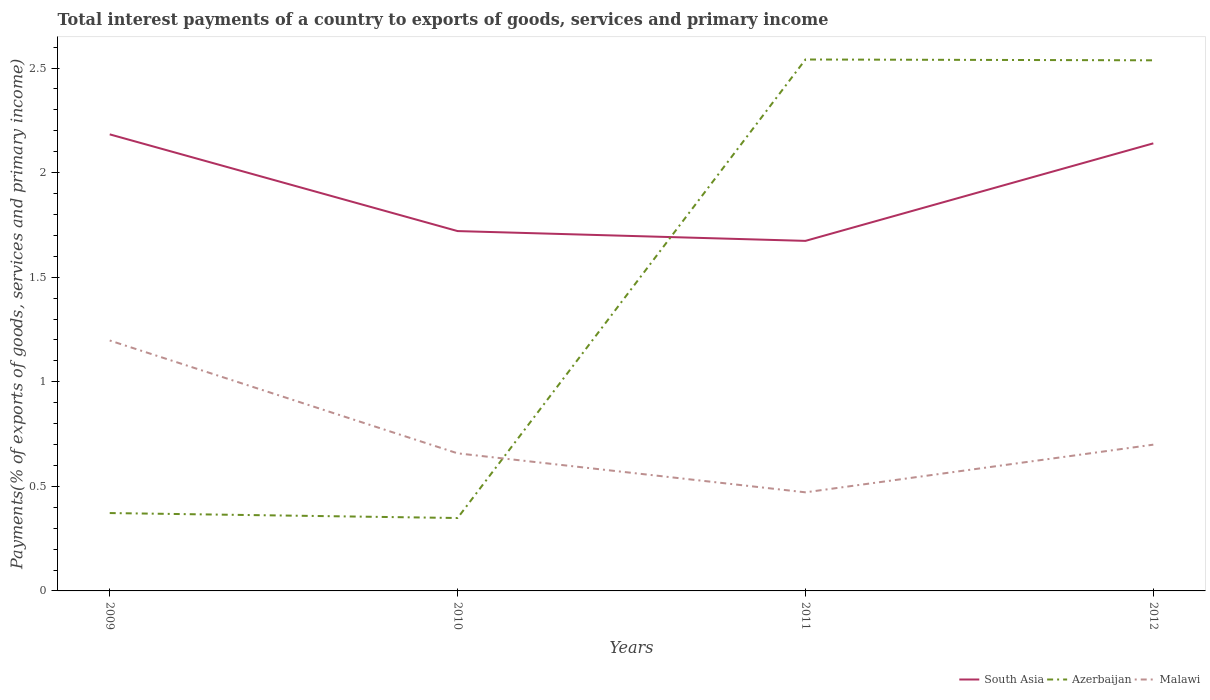Does the line corresponding to Azerbaijan intersect with the line corresponding to Malawi?
Your answer should be compact. Yes. Across all years, what is the maximum total interest payments in Malawi?
Your answer should be compact. 0.47. What is the total total interest payments in South Asia in the graph?
Offer a terse response. 0.46. What is the difference between the highest and the second highest total interest payments in Azerbaijan?
Make the answer very short. 2.19. What is the difference between the highest and the lowest total interest payments in Azerbaijan?
Offer a terse response. 2. How many lines are there?
Your answer should be very brief. 3. What is the difference between two consecutive major ticks on the Y-axis?
Your response must be concise. 0.5. Are the values on the major ticks of Y-axis written in scientific E-notation?
Offer a terse response. No. Does the graph contain grids?
Ensure brevity in your answer.  No. What is the title of the graph?
Your answer should be very brief. Total interest payments of a country to exports of goods, services and primary income. What is the label or title of the Y-axis?
Provide a succinct answer. Payments(% of exports of goods, services and primary income). What is the Payments(% of exports of goods, services and primary income) of South Asia in 2009?
Keep it short and to the point. 2.18. What is the Payments(% of exports of goods, services and primary income) of Azerbaijan in 2009?
Give a very brief answer. 0.37. What is the Payments(% of exports of goods, services and primary income) in Malawi in 2009?
Give a very brief answer. 1.2. What is the Payments(% of exports of goods, services and primary income) of South Asia in 2010?
Make the answer very short. 1.72. What is the Payments(% of exports of goods, services and primary income) in Azerbaijan in 2010?
Offer a terse response. 0.35. What is the Payments(% of exports of goods, services and primary income) in Malawi in 2010?
Your answer should be compact. 0.66. What is the Payments(% of exports of goods, services and primary income) of South Asia in 2011?
Ensure brevity in your answer.  1.67. What is the Payments(% of exports of goods, services and primary income) of Azerbaijan in 2011?
Your answer should be compact. 2.54. What is the Payments(% of exports of goods, services and primary income) of Malawi in 2011?
Make the answer very short. 0.47. What is the Payments(% of exports of goods, services and primary income) in South Asia in 2012?
Your response must be concise. 2.14. What is the Payments(% of exports of goods, services and primary income) in Azerbaijan in 2012?
Your answer should be compact. 2.54. What is the Payments(% of exports of goods, services and primary income) of Malawi in 2012?
Offer a very short reply. 0.7. Across all years, what is the maximum Payments(% of exports of goods, services and primary income) in South Asia?
Your answer should be compact. 2.18. Across all years, what is the maximum Payments(% of exports of goods, services and primary income) of Azerbaijan?
Your response must be concise. 2.54. Across all years, what is the maximum Payments(% of exports of goods, services and primary income) in Malawi?
Offer a terse response. 1.2. Across all years, what is the minimum Payments(% of exports of goods, services and primary income) in South Asia?
Keep it short and to the point. 1.67. Across all years, what is the minimum Payments(% of exports of goods, services and primary income) of Azerbaijan?
Your answer should be very brief. 0.35. Across all years, what is the minimum Payments(% of exports of goods, services and primary income) in Malawi?
Provide a short and direct response. 0.47. What is the total Payments(% of exports of goods, services and primary income) of South Asia in the graph?
Ensure brevity in your answer.  7.72. What is the total Payments(% of exports of goods, services and primary income) of Azerbaijan in the graph?
Provide a succinct answer. 5.8. What is the total Payments(% of exports of goods, services and primary income) in Malawi in the graph?
Make the answer very short. 3.03. What is the difference between the Payments(% of exports of goods, services and primary income) in South Asia in 2009 and that in 2010?
Your answer should be compact. 0.46. What is the difference between the Payments(% of exports of goods, services and primary income) of Azerbaijan in 2009 and that in 2010?
Your answer should be very brief. 0.02. What is the difference between the Payments(% of exports of goods, services and primary income) of Malawi in 2009 and that in 2010?
Your response must be concise. 0.54. What is the difference between the Payments(% of exports of goods, services and primary income) in South Asia in 2009 and that in 2011?
Provide a succinct answer. 0.51. What is the difference between the Payments(% of exports of goods, services and primary income) in Azerbaijan in 2009 and that in 2011?
Your answer should be compact. -2.17. What is the difference between the Payments(% of exports of goods, services and primary income) in Malawi in 2009 and that in 2011?
Provide a succinct answer. 0.73. What is the difference between the Payments(% of exports of goods, services and primary income) of South Asia in 2009 and that in 2012?
Provide a succinct answer. 0.04. What is the difference between the Payments(% of exports of goods, services and primary income) of Azerbaijan in 2009 and that in 2012?
Provide a succinct answer. -2.16. What is the difference between the Payments(% of exports of goods, services and primary income) in Malawi in 2009 and that in 2012?
Keep it short and to the point. 0.5. What is the difference between the Payments(% of exports of goods, services and primary income) in South Asia in 2010 and that in 2011?
Keep it short and to the point. 0.05. What is the difference between the Payments(% of exports of goods, services and primary income) of Azerbaijan in 2010 and that in 2011?
Your answer should be compact. -2.19. What is the difference between the Payments(% of exports of goods, services and primary income) of Malawi in 2010 and that in 2011?
Provide a succinct answer. 0.19. What is the difference between the Payments(% of exports of goods, services and primary income) in South Asia in 2010 and that in 2012?
Make the answer very short. -0.42. What is the difference between the Payments(% of exports of goods, services and primary income) of Azerbaijan in 2010 and that in 2012?
Your response must be concise. -2.19. What is the difference between the Payments(% of exports of goods, services and primary income) in Malawi in 2010 and that in 2012?
Your response must be concise. -0.04. What is the difference between the Payments(% of exports of goods, services and primary income) in South Asia in 2011 and that in 2012?
Offer a very short reply. -0.47. What is the difference between the Payments(% of exports of goods, services and primary income) of Azerbaijan in 2011 and that in 2012?
Make the answer very short. 0. What is the difference between the Payments(% of exports of goods, services and primary income) of Malawi in 2011 and that in 2012?
Offer a very short reply. -0.23. What is the difference between the Payments(% of exports of goods, services and primary income) of South Asia in 2009 and the Payments(% of exports of goods, services and primary income) of Azerbaijan in 2010?
Your response must be concise. 1.83. What is the difference between the Payments(% of exports of goods, services and primary income) of South Asia in 2009 and the Payments(% of exports of goods, services and primary income) of Malawi in 2010?
Provide a short and direct response. 1.53. What is the difference between the Payments(% of exports of goods, services and primary income) in Azerbaijan in 2009 and the Payments(% of exports of goods, services and primary income) in Malawi in 2010?
Your answer should be compact. -0.29. What is the difference between the Payments(% of exports of goods, services and primary income) of South Asia in 2009 and the Payments(% of exports of goods, services and primary income) of Azerbaijan in 2011?
Your answer should be compact. -0.36. What is the difference between the Payments(% of exports of goods, services and primary income) of South Asia in 2009 and the Payments(% of exports of goods, services and primary income) of Malawi in 2011?
Provide a short and direct response. 1.71. What is the difference between the Payments(% of exports of goods, services and primary income) in Azerbaijan in 2009 and the Payments(% of exports of goods, services and primary income) in Malawi in 2011?
Make the answer very short. -0.1. What is the difference between the Payments(% of exports of goods, services and primary income) in South Asia in 2009 and the Payments(% of exports of goods, services and primary income) in Azerbaijan in 2012?
Make the answer very short. -0.35. What is the difference between the Payments(% of exports of goods, services and primary income) in South Asia in 2009 and the Payments(% of exports of goods, services and primary income) in Malawi in 2012?
Make the answer very short. 1.48. What is the difference between the Payments(% of exports of goods, services and primary income) of Azerbaijan in 2009 and the Payments(% of exports of goods, services and primary income) of Malawi in 2012?
Offer a very short reply. -0.33. What is the difference between the Payments(% of exports of goods, services and primary income) of South Asia in 2010 and the Payments(% of exports of goods, services and primary income) of Azerbaijan in 2011?
Offer a terse response. -0.82. What is the difference between the Payments(% of exports of goods, services and primary income) of South Asia in 2010 and the Payments(% of exports of goods, services and primary income) of Malawi in 2011?
Keep it short and to the point. 1.25. What is the difference between the Payments(% of exports of goods, services and primary income) of Azerbaijan in 2010 and the Payments(% of exports of goods, services and primary income) of Malawi in 2011?
Keep it short and to the point. -0.12. What is the difference between the Payments(% of exports of goods, services and primary income) of South Asia in 2010 and the Payments(% of exports of goods, services and primary income) of Azerbaijan in 2012?
Offer a very short reply. -0.82. What is the difference between the Payments(% of exports of goods, services and primary income) of South Asia in 2010 and the Payments(% of exports of goods, services and primary income) of Malawi in 2012?
Your answer should be compact. 1.02. What is the difference between the Payments(% of exports of goods, services and primary income) of Azerbaijan in 2010 and the Payments(% of exports of goods, services and primary income) of Malawi in 2012?
Your answer should be very brief. -0.35. What is the difference between the Payments(% of exports of goods, services and primary income) of South Asia in 2011 and the Payments(% of exports of goods, services and primary income) of Azerbaijan in 2012?
Your response must be concise. -0.86. What is the difference between the Payments(% of exports of goods, services and primary income) of South Asia in 2011 and the Payments(% of exports of goods, services and primary income) of Malawi in 2012?
Offer a terse response. 0.97. What is the difference between the Payments(% of exports of goods, services and primary income) of Azerbaijan in 2011 and the Payments(% of exports of goods, services and primary income) of Malawi in 2012?
Provide a succinct answer. 1.84. What is the average Payments(% of exports of goods, services and primary income) of South Asia per year?
Provide a succinct answer. 1.93. What is the average Payments(% of exports of goods, services and primary income) in Azerbaijan per year?
Give a very brief answer. 1.45. What is the average Payments(% of exports of goods, services and primary income) of Malawi per year?
Keep it short and to the point. 0.76. In the year 2009, what is the difference between the Payments(% of exports of goods, services and primary income) of South Asia and Payments(% of exports of goods, services and primary income) of Azerbaijan?
Make the answer very short. 1.81. In the year 2009, what is the difference between the Payments(% of exports of goods, services and primary income) in South Asia and Payments(% of exports of goods, services and primary income) in Malawi?
Provide a short and direct response. 0.99. In the year 2009, what is the difference between the Payments(% of exports of goods, services and primary income) of Azerbaijan and Payments(% of exports of goods, services and primary income) of Malawi?
Give a very brief answer. -0.82. In the year 2010, what is the difference between the Payments(% of exports of goods, services and primary income) of South Asia and Payments(% of exports of goods, services and primary income) of Azerbaijan?
Your response must be concise. 1.37. In the year 2010, what is the difference between the Payments(% of exports of goods, services and primary income) in South Asia and Payments(% of exports of goods, services and primary income) in Malawi?
Your answer should be very brief. 1.06. In the year 2010, what is the difference between the Payments(% of exports of goods, services and primary income) in Azerbaijan and Payments(% of exports of goods, services and primary income) in Malawi?
Ensure brevity in your answer.  -0.31. In the year 2011, what is the difference between the Payments(% of exports of goods, services and primary income) in South Asia and Payments(% of exports of goods, services and primary income) in Azerbaijan?
Your response must be concise. -0.87. In the year 2011, what is the difference between the Payments(% of exports of goods, services and primary income) in South Asia and Payments(% of exports of goods, services and primary income) in Malawi?
Your answer should be compact. 1.2. In the year 2011, what is the difference between the Payments(% of exports of goods, services and primary income) in Azerbaijan and Payments(% of exports of goods, services and primary income) in Malawi?
Provide a short and direct response. 2.07. In the year 2012, what is the difference between the Payments(% of exports of goods, services and primary income) in South Asia and Payments(% of exports of goods, services and primary income) in Azerbaijan?
Offer a very short reply. -0.4. In the year 2012, what is the difference between the Payments(% of exports of goods, services and primary income) in South Asia and Payments(% of exports of goods, services and primary income) in Malawi?
Provide a succinct answer. 1.44. In the year 2012, what is the difference between the Payments(% of exports of goods, services and primary income) of Azerbaijan and Payments(% of exports of goods, services and primary income) of Malawi?
Offer a very short reply. 1.84. What is the ratio of the Payments(% of exports of goods, services and primary income) in South Asia in 2009 to that in 2010?
Ensure brevity in your answer.  1.27. What is the ratio of the Payments(% of exports of goods, services and primary income) in Azerbaijan in 2009 to that in 2010?
Make the answer very short. 1.07. What is the ratio of the Payments(% of exports of goods, services and primary income) of Malawi in 2009 to that in 2010?
Your answer should be compact. 1.82. What is the ratio of the Payments(% of exports of goods, services and primary income) of South Asia in 2009 to that in 2011?
Keep it short and to the point. 1.3. What is the ratio of the Payments(% of exports of goods, services and primary income) in Azerbaijan in 2009 to that in 2011?
Your answer should be very brief. 0.15. What is the ratio of the Payments(% of exports of goods, services and primary income) of Malawi in 2009 to that in 2011?
Your answer should be very brief. 2.54. What is the ratio of the Payments(% of exports of goods, services and primary income) in South Asia in 2009 to that in 2012?
Your answer should be compact. 1.02. What is the ratio of the Payments(% of exports of goods, services and primary income) in Azerbaijan in 2009 to that in 2012?
Your response must be concise. 0.15. What is the ratio of the Payments(% of exports of goods, services and primary income) of Malawi in 2009 to that in 2012?
Keep it short and to the point. 1.71. What is the ratio of the Payments(% of exports of goods, services and primary income) of South Asia in 2010 to that in 2011?
Ensure brevity in your answer.  1.03. What is the ratio of the Payments(% of exports of goods, services and primary income) of Azerbaijan in 2010 to that in 2011?
Your answer should be compact. 0.14. What is the ratio of the Payments(% of exports of goods, services and primary income) of Malawi in 2010 to that in 2011?
Your response must be concise. 1.4. What is the ratio of the Payments(% of exports of goods, services and primary income) in South Asia in 2010 to that in 2012?
Make the answer very short. 0.8. What is the ratio of the Payments(% of exports of goods, services and primary income) of Azerbaijan in 2010 to that in 2012?
Offer a very short reply. 0.14. What is the ratio of the Payments(% of exports of goods, services and primary income) in Malawi in 2010 to that in 2012?
Offer a terse response. 0.94. What is the ratio of the Payments(% of exports of goods, services and primary income) of South Asia in 2011 to that in 2012?
Your answer should be very brief. 0.78. What is the ratio of the Payments(% of exports of goods, services and primary income) in Azerbaijan in 2011 to that in 2012?
Make the answer very short. 1. What is the ratio of the Payments(% of exports of goods, services and primary income) in Malawi in 2011 to that in 2012?
Make the answer very short. 0.67. What is the difference between the highest and the second highest Payments(% of exports of goods, services and primary income) of South Asia?
Give a very brief answer. 0.04. What is the difference between the highest and the second highest Payments(% of exports of goods, services and primary income) in Azerbaijan?
Give a very brief answer. 0. What is the difference between the highest and the second highest Payments(% of exports of goods, services and primary income) in Malawi?
Your answer should be compact. 0.5. What is the difference between the highest and the lowest Payments(% of exports of goods, services and primary income) of South Asia?
Provide a succinct answer. 0.51. What is the difference between the highest and the lowest Payments(% of exports of goods, services and primary income) of Azerbaijan?
Ensure brevity in your answer.  2.19. What is the difference between the highest and the lowest Payments(% of exports of goods, services and primary income) of Malawi?
Make the answer very short. 0.73. 